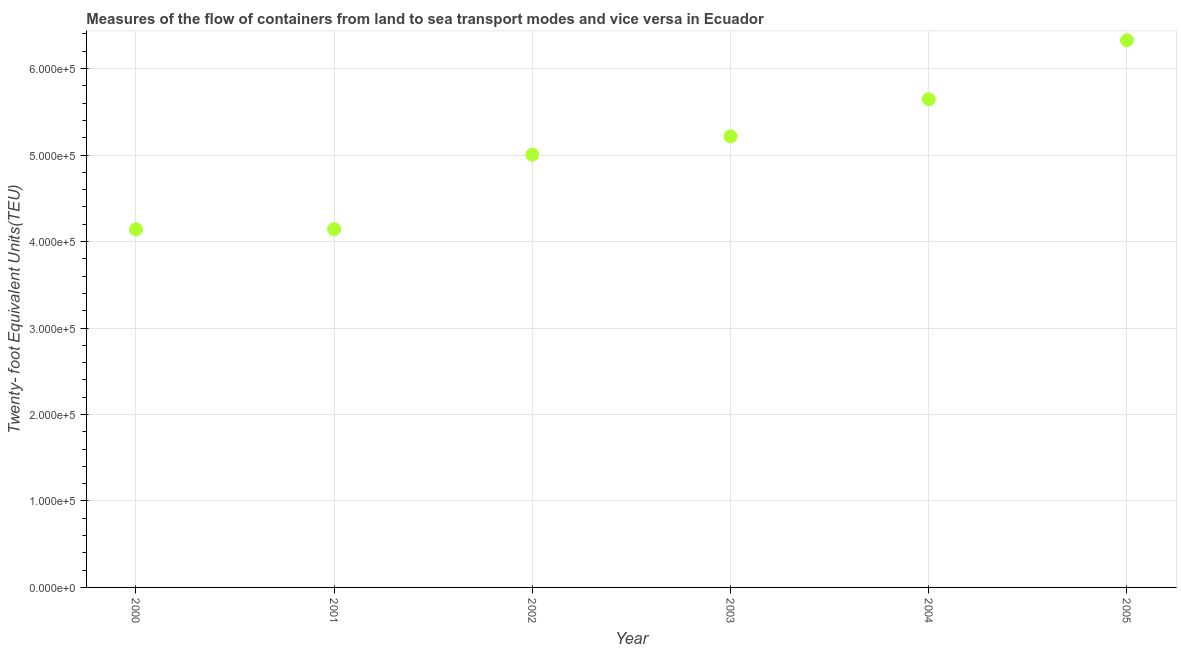What is the container port traffic in 2004?
Your answer should be very brief. 5.65e+05. Across all years, what is the maximum container port traffic?
Make the answer very short. 6.33e+05. Across all years, what is the minimum container port traffic?
Your answer should be compact. 4.14e+05. In which year was the container port traffic maximum?
Keep it short and to the point. 2005. What is the sum of the container port traffic?
Offer a terse response. 3.05e+06. What is the difference between the container port traffic in 2002 and 2005?
Ensure brevity in your answer.  -1.32e+05. What is the average container port traffic per year?
Provide a short and direct response. 5.08e+05. What is the median container port traffic?
Provide a short and direct response. 5.11e+05. In how many years, is the container port traffic greater than 100000 TEU?
Provide a succinct answer. 6. Do a majority of the years between 2000 and 2001 (inclusive) have container port traffic greater than 380000 TEU?
Offer a terse response. Yes. What is the ratio of the container port traffic in 2002 to that in 2005?
Your response must be concise. 0.79. What is the difference between the highest and the second highest container port traffic?
Your response must be concise. 6.82e+04. Is the sum of the container port traffic in 2000 and 2004 greater than the maximum container port traffic across all years?
Offer a terse response. Yes. What is the difference between the highest and the lowest container port traffic?
Offer a very short reply. 2.19e+05. Does the container port traffic monotonically increase over the years?
Make the answer very short. Yes. How many years are there in the graph?
Offer a terse response. 6. Are the values on the major ticks of Y-axis written in scientific E-notation?
Your answer should be very brief. Yes. What is the title of the graph?
Make the answer very short. Measures of the flow of containers from land to sea transport modes and vice versa in Ecuador. What is the label or title of the X-axis?
Offer a terse response. Year. What is the label or title of the Y-axis?
Keep it short and to the point. Twenty- foot Equivalent Units(TEU). What is the Twenty- foot Equivalent Units(TEU) in 2000?
Ensure brevity in your answer.  4.14e+05. What is the Twenty- foot Equivalent Units(TEU) in 2001?
Give a very brief answer. 4.14e+05. What is the Twenty- foot Equivalent Units(TEU) in 2002?
Keep it short and to the point. 5.00e+05. What is the Twenty- foot Equivalent Units(TEU) in 2003?
Provide a short and direct response. 5.22e+05. What is the Twenty- foot Equivalent Units(TEU) in 2004?
Offer a terse response. 5.65e+05. What is the Twenty- foot Equivalent Units(TEU) in 2005?
Keep it short and to the point. 6.33e+05. What is the difference between the Twenty- foot Equivalent Units(TEU) in 2000 and 2001?
Offer a very short reply. -251. What is the difference between the Twenty- foot Equivalent Units(TEU) in 2000 and 2002?
Ensure brevity in your answer.  -8.64e+04. What is the difference between the Twenty- foot Equivalent Units(TEU) in 2000 and 2003?
Your answer should be compact. -1.07e+05. What is the difference between the Twenty- foot Equivalent Units(TEU) in 2000 and 2004?
Your answer should be compact. -1.50e+05. What is the difference between the Twenty- foot Equivalent Units(TEU) in 2000 and 2005?
Offer a terse response. -2.19e+05. What is the difference between the Twenty- foot Equivalent Units(TEU) in 2001 and 2002?
Offer a very short reply. -8.61e+04. What is the difference between the Twenty- foot Equivalent Units(TEU) in 2001 and 2003?
Give a very brief answer. -1.07e+05. What is the difference between the Twenty- foot Equivalent Units(TEU) in 2001 and 2004?
Offer a very short reply. -1.50e+05. What is the difference between the Twenty- foot Equivalent Units(TEU) in 2001 and 2005?
Provide a succinct answer. -2.18e+05. What is the difference between the Twenty- foot Equivalent Units(TEU) in 2002 and 2003?
Make the answer very short. -2.11e+04. What is the difference between the Twenty- foot Equivalent Units(TEU) in 2002 and 2004?
Your response must be concise. -6.40e+04. What is the difference between the Twenty- foot Equivalent Units(TEU) in 2002 and 2005?
Give a very brief answer. -1.32e+05. What is the difference between the Twenty- foot Equivalent Units(TEU) in 2003 and 2004?
Give a very brief answer. -4.30e+04. What is the difference between the Twenty- foot Equivalent Units(TEU) in 2003 and 2005?
Provide a short and direct response. -1.11e+05. What is the difference between the Twenty- foot Equivalent Units(TEU) in 2004 and 2005?
Make the answer very short. -6.82e+04. What is the ratio of the Twenty- foot Equivalent Units(TEU) in 2000 to that in 2001?
Offer a terse response. 1. What is the ratio of the Twenty- foot Equivalent Units(TEU) in 2000 to that in 2002?
Keep it short and to the point. 0.83. What is the ratio of the Twenty- foot Equivalent Units(TEU) in 2000 to that in 2003?
Your answer should be compact. 0.79. What is the ratio of the Twenty- foot Equivalent Units(TEU) in 2000 to that in 2004?
Offer a terse response. 0.73. What is the ratio of the Twenty- foot Equivalent Units(TEU) in 2000 to that in 2005?
Give a very brief answer. 0.65. What is the ratio of the Twenty- foot Equivalent Units(TEU) in 2001 to that in 2002?
Offer a very short reply. 0.83. What is the ratio of the Twenty- foot Equivalent Units(TEU) in 2001 to that in 2003?
Your answer should be compact. 0.79. What is the ratio of the Twenty- foot Equivalent Units(TEU) in 2001 to that in 2004?
Your answer should be compact. 0.73. What is the ratio of the Twenty- foot Equivalent Units(TEU) in 2001 to that in 2005?
Your answer should be very brief. 0.66. What is the ratio of the Twenty- foot Equivalent Units(TEU) in 2002 to that in 2004?
Offer a terse response. 0.89. What is the ratio of the Twenty- foot Equivalent Units(TEU) in 2002 to that in 2005?
Offer a terse response. 0.79. What is the ratio of the Twenty- foot Equivalent Units(TEU) in 2003 to that in 2004?
Offer a very short reply. 0.92. What is the ratio of the Twenty- foot Equivalent Units(TEU) in 2003 to that in 2005?
Offer a terse response. 0.82. What is the ratio of the Twenty- foot Equivalent Units(TEU) in 2004 to that in 2005?
Make the answer very short. 0.89. 